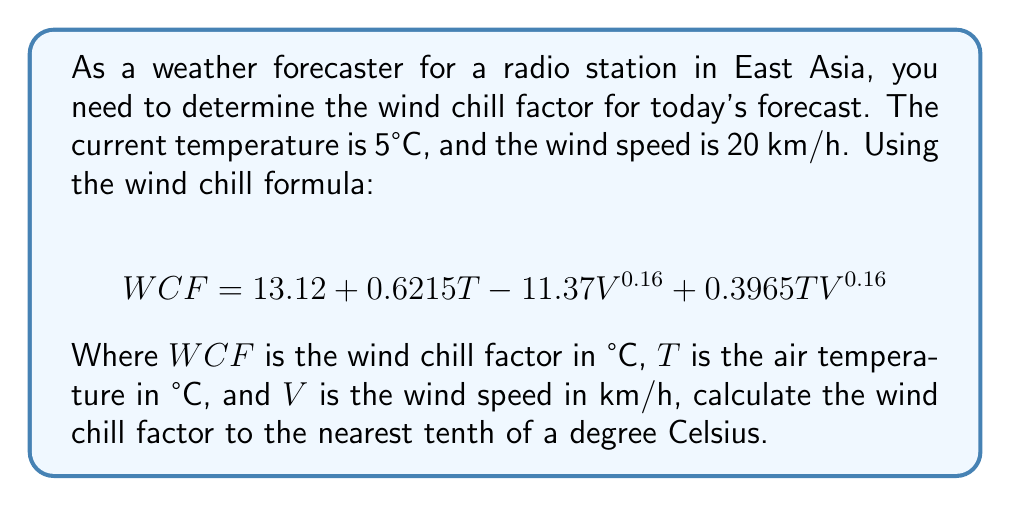Teach me how to tackle this problem. To solve this problem, we'll follow these steps:

1. Identify the given values:
   $T = 5°C$
   $V = 20$ km/h

2. Substitute these values into the wind chill formula:
   $$WCF = 13.12 + 0.6215(5) - 11.37(20)^{0.16} + 0.3965(5)(20)^{0.16}$$

3. Calculate the exponent: $20^{0.16} ≈ 1.8114$

4. Solve each part of the equation:
   - $13.12$ (constant term)
   - $0.6215(5) = 3.1075$
   - $11.37(1.8114) = 20.5956$
   - $0.3965(5)(1.8114) = 3.5896$

5. Combine the terms:
   $$WCF = 13.12 + 3.1075 - 20.5956 + 3.5896$$

6. Perform the final calculation:
   $$WCF = -0.7785$$

7. Round to the nearest tenth:
   $$WCF ≈ -0.8°C$$
Answer: $-0.8°C$ 